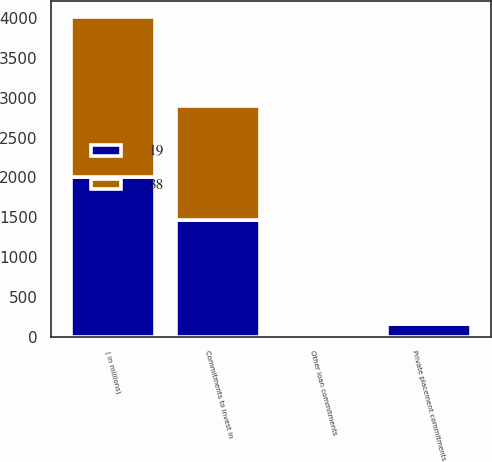Convert chart to OTSL. <chart><loc_0><loc_0><loc_500><loc_500><stacked_bar_chart><ecel><fcel>( in millions)<fcel>Commitments to invest in<fcel>Private placement commitments<fcel>Other loan commitments<nl><fcel>19<fcel>2010<fcel>1471<fcel>159<fcel>38<nl><fcel>38<fcel>2009<fcel>1432<fcel>7<fcel>19<nl></chart> 